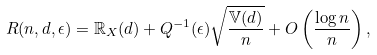<formula> <loc_0><loc_0><loc_500><loc_500>R ( n , d , \epsilon ) = \mathbb { R } _ { X } ( d ) + Q ^ { - 1 } ( \epsilon ) \sqrt { \frac { \mathbb { V } ( d ) } { n } } + O \left ( \frac { \log n } { n } \right ) ,</formula> 